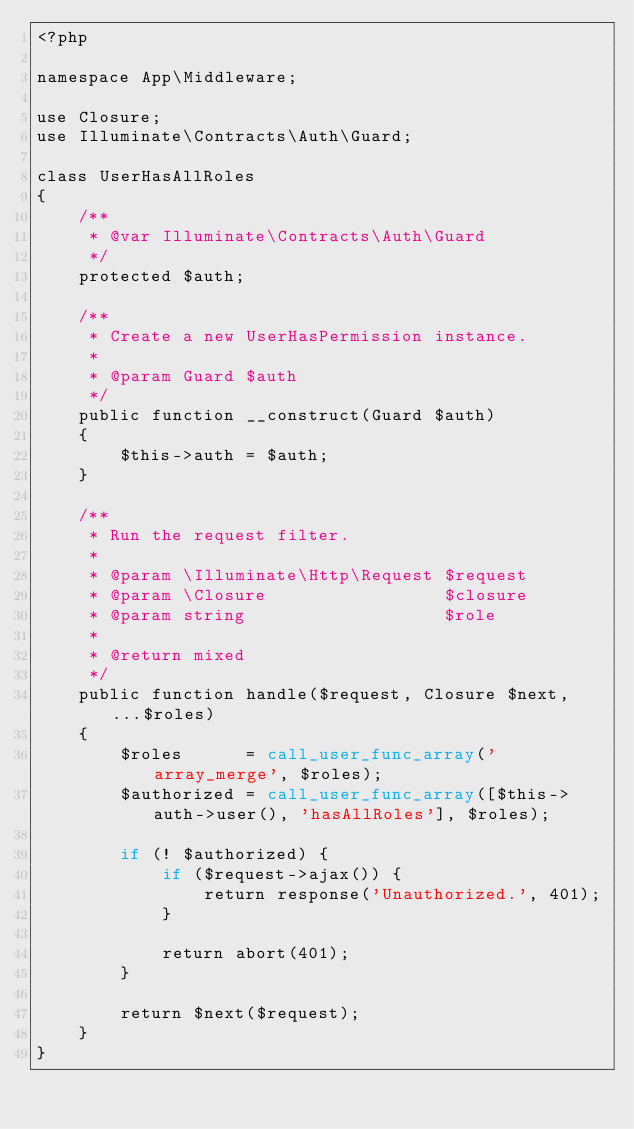Convert code to text. <code><loc_0><loc_0><loc_500><loc_500><_PHP_><?php

namespace App\Middleware;

use Closure;
use Illuminate\Contracts\Auth\Guard;

class UserHasAllRoles
{
    /**
     * @var Illuminate\Contracts\Auth\Guard
     */
    protected $auth;

    /**
     * Create a new UserHasPermission instance.
     *
     * @param Guard $auth
     */
    public function __construct(Guard $auth)
    {
        $this->auth = $auth;
    }

    /**
     * Run the request filter.
     *
     * @param \Illuminate\Http\Request $request
     * @param \Closure                 $closure
     * @param string                   $role
     *
     * @return mixed
     */
    public function handle($request, Closure $next, ...$roles)
    {
        $roles      = call_user_func_array('array_merge', $roles);
        $authorized = call_user_func_array([$this->auth->user(), 'hasAllRoles'], $roles);

        if (! $authorized) {
            if ($request->ajax()) {
                return response('Unauthorized.', 401);
            }

            return abort(401);
        }

        return $next($request);
    }
}
</code> 